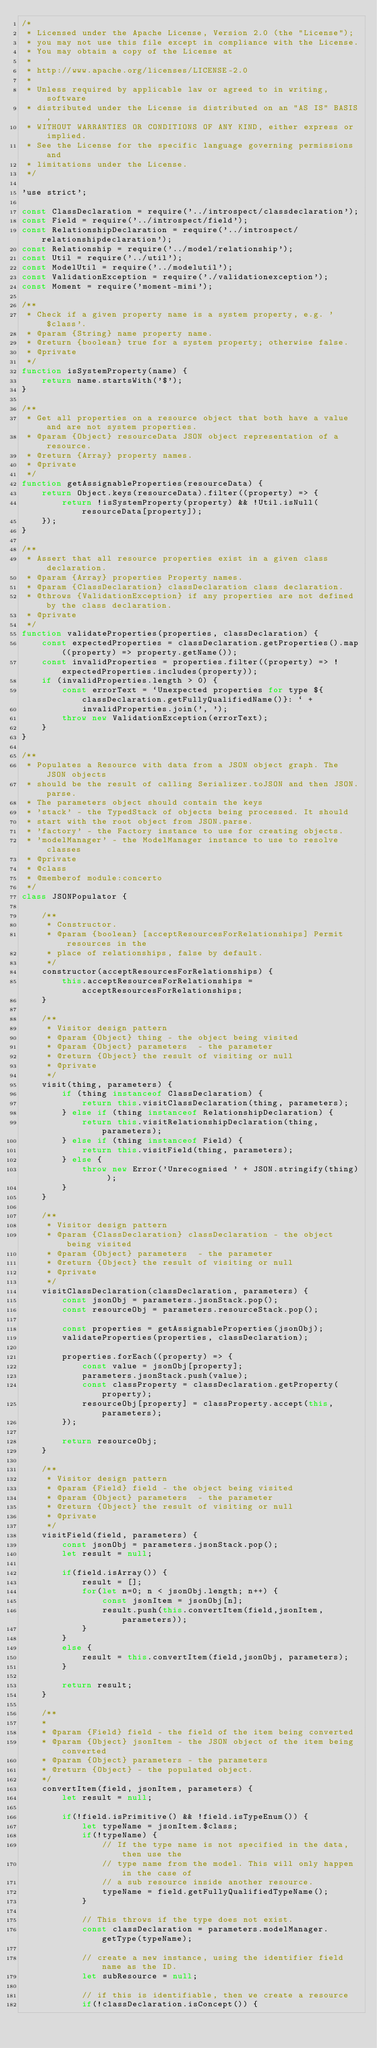<code> <loc_0><loc_0><loc_500><loc_500><_JavaScript_>/*
 * Licensed under the Apache License, Version 2.0 (the "License");
 * you may not use this file except in compliance with the License.
 * You may obtain a copy of the License at
 *
 * http://www.apache.org/licenses/LICENSE-2.0
 *
 * Unless required by applicable law or agreed to in writing, software
 * distributed under the License is distributed on an "AS IS" BASIS,
 * WITHOUT WARRANTIES OR CONDITIONS OF ANY KIND, either express or implied.
 * See the License for the specific language governing permissions and
 * limitations under the License.
 */

'use strict';

const ClassDeclaration = require('../introspect/classdeclaration');
const Field = require('../introspect/field');
const RelationshipDeclaration = require('../introspect/relationshipdeclaration');
const Relationship = require('../model/relationship');
const Util = require('../util');
const ModelUtil = require('../modelutil');
const ValidationException = require('./validationexception');
const Moment = require('moment-mini');

/**
 * Check if a given property name is a system property, e.g. '$class'.
 * @param {String} name property name.
 * @return {boolean} true for a system property; otherwise false.
 * @private
 */
function isSystemProperty(name) {
    return name.startsWith('$');
}

/**
 * Get all properties on a resource object that both have a value and are not system properties.
 * @param {Object} resourceData JSON object representation of a resource.
 * @return {Array} property names.
 * @private
 */
function getAssignableProperties(resourceData) {
    return Object.keys(resourceData).filter((property) => {
        return !isSystemProperty(property) && !Util.isNull(resourceData[property]);
    });
}

/**
 * Assert that all resource properties exist in a given class declaration.
 * @param {Array} properties Property names.
 * @param {ClassDeclaration} classDeclaration class declaration.
 * @throws {ValidationException} if any properties are not defined by the class declaration.
 * @private
 */
function validateProperties(properties, classDeclaration) {
    const expectedProperties = classDeclaration.getProperties().map((property) => property.getName());
    const invalidProperties = properties.filter((property) => !expectedProperties.includes(property));
    if (invalidProperties.length > 0) {
        const errorText = `Unexpected properties for type ${classDeclaration.getFullyQualifiedName()}: ` +
            invalidProperties.join(', ');
        throw new ValidationException(errorText);
    }
}

/**
 * Populates a Resource with data from a JSON object graph. The JSON objects
 * should be the result of calling Serializer.toJSON and then JSON.parse.
 * The parameters object should contain the keys
 * 'stack' - the TypedStack of objects being processed. It should
 * start with the root object from JSON.parse.
 * 'factory' - the Factory instance to use for creating objects.
 * 'modelManager' - the ModelManager instance to use to resolve classes
 * @private
 * @class
 * @memberof module:concerto
 */
class JSONPopulator {

    /**
     * Constructor.
     * @param {boolean} [acceptResourcesForRelationships] Permit resources in the
     * place of relationships, false by default.
     */
    constructor(acceptResourcesForRelationships) {
        this.acceptResourcesForRelationships = acceptResourcesForRelationships;
    }

    /**
     * Visitor design pattern
     * @param {Object} thing - the object being visited
     * @param {Object} parameters  - the parameter
     * @return {Object} the result of visiting or null
     * @private
     */
    visit(thing, parameters) {
        if (thing instanceof ClassDeclaration) {
            return this.visitClassDeclaration(thing, parameters);
        } else if (thing instanceof RelationshipDeclaration) {
            return this.visitRelationshipDeclaration(thing, parameters);
        } else if (thing instanceof Field) {
            return this.visitField(thing, parameters);
        } else {
            throw new Error('Unrecognised ' + JSON.stringify(thing) );
        }
    }

    /**
     * Visitor design pattern
     * @param {ClassDeclaration} classDeclaration - the object being visited
     * @param {Object} parameters  - the parameter
     * @return {Object} the result of visiting or null
     * @private
     */
    visitClassDeclaration(classDeclaration, parameters) {
        const jsonObj = parameters.jsonStack.pop();
        const resourceObj = parameters.resourceStack.pop();

        const properties = getAssignableProperties(jsonObj);
        validateProperties(properties, classDeclaration);

        properties.forEach((property) => {
            const value = jsonObj[property];
            parameters.jsonStack.push(value);
            const classProperty = classDeclaration.getProperty(property);
            resourceObj[property] = classProperty.accept(this,parameters);
        });

        return resourceObj;
    }

    /**
     * Visitor design pattern
     * @param {Field} field - the object being visited
     * @param {Object} parameters  - the parameter
     * @return {Object} the result of visiting or null
     * @private
     */
    visitField(field, parameters) {
        const jsonObj = parameters.jsonStack.pop();
        let result = null;

        if(field.isArray()) {
            result = [];
            for(let n=0; n < jsonObj.length; n++) {
                const jsonItem = jsonObj[n];
                result.push(this.convertItem(field,jsonItem, parameters));
            }
        }
        else {
            result = this.convertItem(field,jsonObj, parameters);
        }

        return result;
    }

    /**
    *
    * @param {Field} field - the field of the item being converted
    * @param {Object} jsonItem - the JSON object of the item being converted
    * @param {Object} parameters - the parameters
    * @return {Object} - the populated object.
    */
    convertItem(field, jsonItem, parameters) {
        let result = null;

        if(!field.isPrimitive() && !field.isTypeEnum()) {
            let typeName = jsonItem.$class;
            if(!typeName) {
                // If the type name is not specified in the data, then use the
                // type name from the model. This will only happen in the case of
                // a sub resource inside another resource.
                typeName = field.getFullyQualifiedTypeName();
            }

            // This throws if the type does not exist.
            const classDeclaration = parameters.modelManager.getType(typeName);

            // create a new instance, using the identifier field name as the ID.
            let subResource = null;

            // if this is identifiable, then we create a resource
            if(!classDeclaration.isConcept()) {</code> 